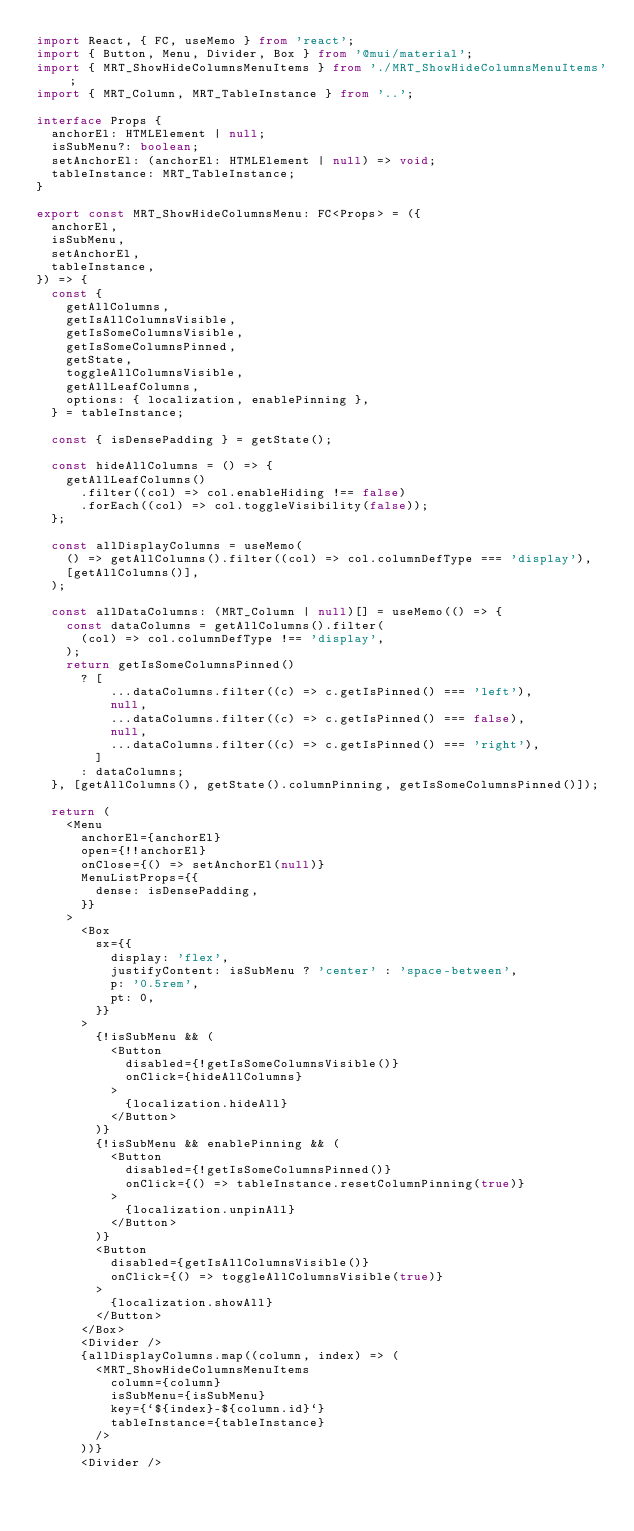<code> <loc_0><loc_0><loc_500><loc_500><_TypeScript_>import React, { FC, useMemo } from 'react';
import { Button, Menu, Divider, Box } from '@mui/material';
import { MRT_ShowHideColumnsMenuItems } from './MRT_ShowHideColumnsMenuItems';
import { MRT_Column, MRT_TableInstance } from '..';

interface Props {
  anchorEl: HTMLElement | null;
  isSubMenu?: boolean;
  setAnchorEl: (anchorEl: HTMLElement | null) => void;
  tableInstance: MRT_TableInstance;
}

export const MRT_ShowHideColumnsMenu: FC<Props> = ({
  anchorEl,
  isSubMenu,
  setAnchorEl,
  tableInstance,
}) => {
  const {
    getAllColumns,
    getIsAllColumnsVisible,
    getIsSomeColumnsVisible,
    getIsSomeColumnsPinned,
    getState,
    toggleAllColumnsVisible,
    getAllLeafColumns,
    options: { localization, enablePinning },
  } = tableInstance;

  const { isDensePadding } = getState();

  const hideAllColumns = () => {
    getAllLeafColumns()
      .filter((col) => col.enableHiding !== false)
      .forEach((col) => col.toggleVisibility(false));
  };

  const allDisplayColumns = useMemo(
    () => getAllColumns().filter((col) => col.columnDefType === 'display'),
    [getAllColumns()],
  );

  const allDataColumns: (MRT_Column | null)[] = useMemo(() => {
    const dataColumns = getAllColumns().filter(
      (col) => col.columnDefType !== 'display',
    );
    return getIsSomeColumnsPinned()
      ? [
          ...dataColumns.filter((c) => c.getIsPinned() === 'left'),
          null,
          ...dataColumns.filter((c) => c.getIsPinned() === false),
          null,
          ...dataColumns.filter((c) => c.getIsPinned() === 'right'),
        ]
      : dataColumns;
  }, [getAllColumns(), getState().columnPinning, getIsSomeColumnsPinned()]);

  return (
    <Menu
      anchorEl={anchorEl}
      open={!!anchorEl}
      onClose={() => setAnchorEl(null)}
      MenuListProps={{
        dense: isDensePadding,
      }}
    >
      <Box
        sx={{
          display: 'flex',
          justifyContent: isSubMenu ? 'center' : 'space-between',
          p: '0.5rem',
          pt: 0,
        }}
      >
        {!isSubMenu && (
          <Button
            disabled={!getIsSomeColumnsVisible()}
            onClick={hideAllColumns}
          >
            {localization.hideAll}
          </Button>
        )}
        {!isSubMenu && enablePinning && (
          <Button
            disabled={!getIsSomeColumnsPinned()}
            onClick={() => tableInstance.resetColumnPinning(true)}
          >
            {localization.unpinAll}
          </Button>
        )}
        <Button
          disabled={getIsAllColumnsVisible()}
          onClick={() => toggleAllColumnsVisible(true)}
        >
          {localization.showAll}
        </Button>
      </Box>
      <Divider />
      {allDisplayColumns.map((column, index) => (
        <MRT_ShowHideColumnsMenuItems
          column={column}
          isSubMenu={isSubMenu}
          key={`${index}-${column.id}`}
          tableInstance={tableInstance}
        />
      ))}
      <Divider /></code> 